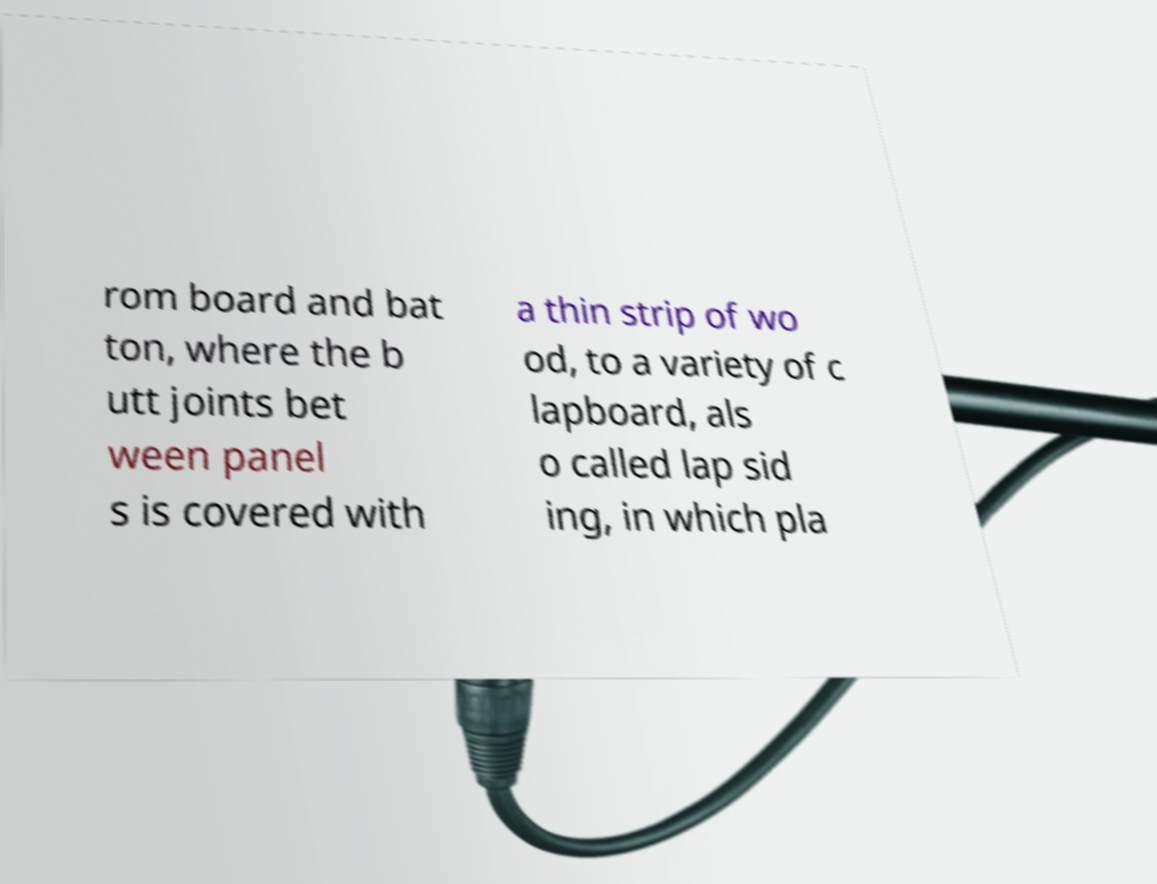Can you read and provide the text displayed in the image?This photo seems to have some interesting text. Can you extract and type it out for me? rom board and bat ton, where the b utt joints bet ween panel s is covered with a thin strip of wo od, to a variety of c lapboard, als o called lap sid ing, in which pla 